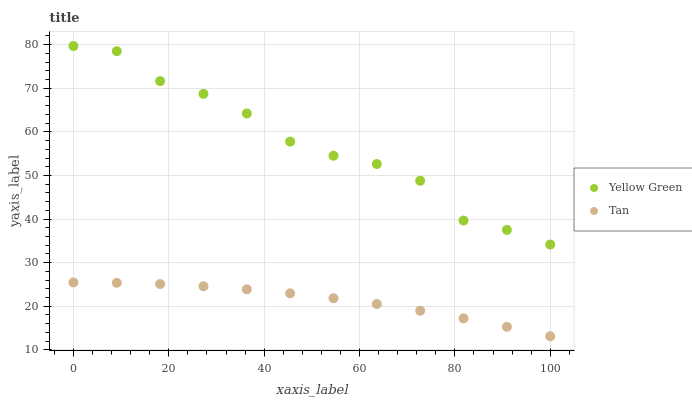Does Tan have the minimum area under the curve?
Answer yes or no. Yes. Does Yellow Green have the maximum area under the curve?
Answer yes or no. Yes. Does Yellow Green have the minimum area under the curve?
Answer yes or no. No. Is Tan the smoothest?
Answer yes or no. Yes. Is Yellow Green the roughest?
Answer yes or no. Yes. Is Yellow Green the smoothest?
Answer yes or no. No. Does Tan have the lowest value?
Answer yes or no. Yes. Does Yellow Green have the lowest value?
Answer yes or no. No. Does Yellow Green have the highest value?
Answer yes or no. Yes. Is Tan less than Yellow Green?
Answer yes or no. Yes. Is Yellow Green greater than Tan?
Answer yes or no. Yes. Does Tan intersect Yellow Green?
Answer yes or no. No. 